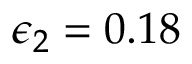<formula> <loc_0><loc_0><loc_500><loc_500>\epsilon _ { 2 } = 0 . 1 8</formula> 